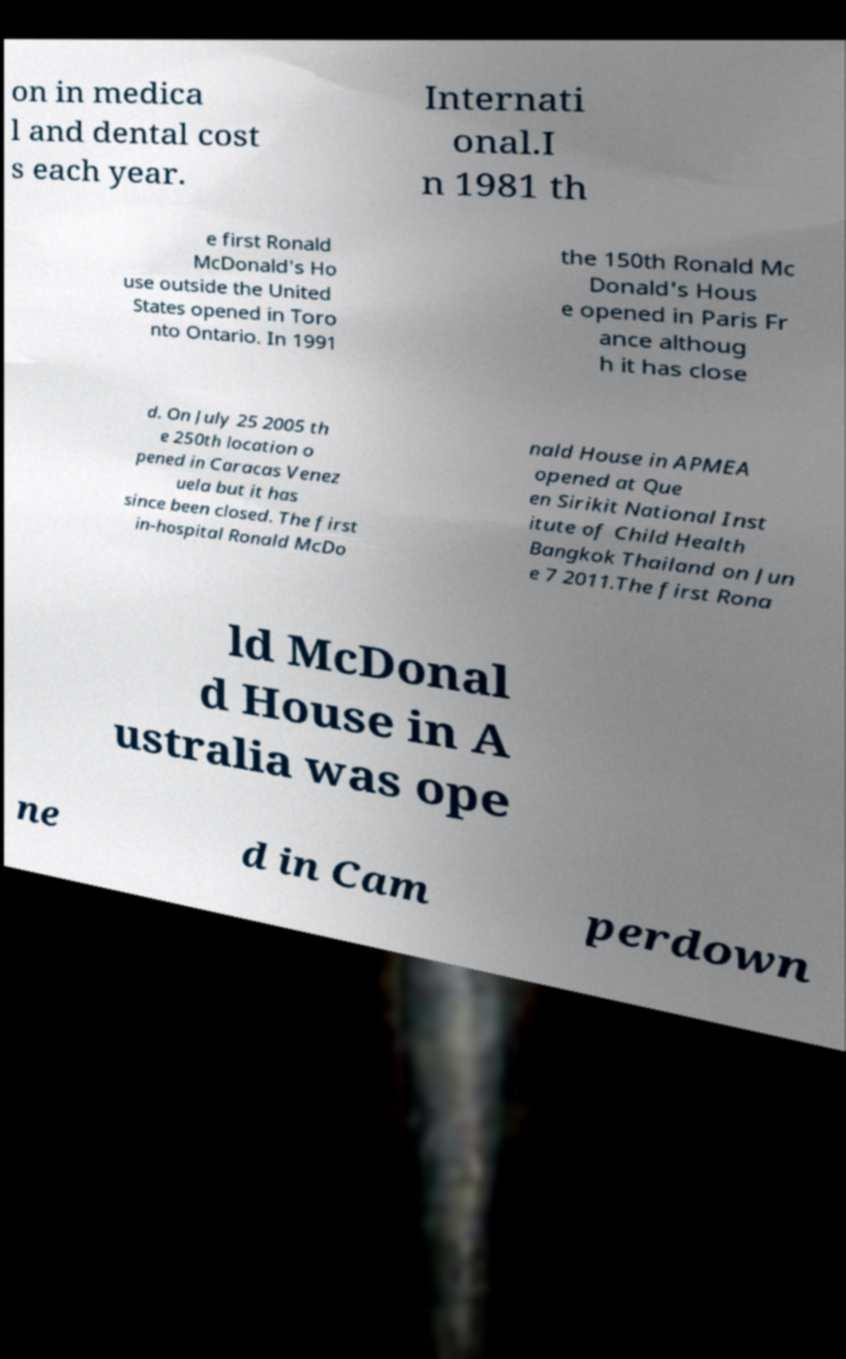I need the written content from this picture converted into text. Can you do that? on in medica l and dental cost s each year. Internati onal.I n 1981 th e first Ronald McDonald's Ho use outside the United States opened in Toro nto Ontario. In 1991 the 150th Ronald Mc Donald's Hous e opened in Paris Fr ance althoug h it has close d. On July 25 2005 th e 250th location o pened in Caracas Venez uela but it has since been closed. The first in-hospital Ronald McDo nald House in APMEA opened at Que en Sirikit National Inst itute of Child Health Bangkok Thailand on Jun e 7 2011.The first Rona ld McDonal d House in A ustralia was ope ne d in Cam perdown 